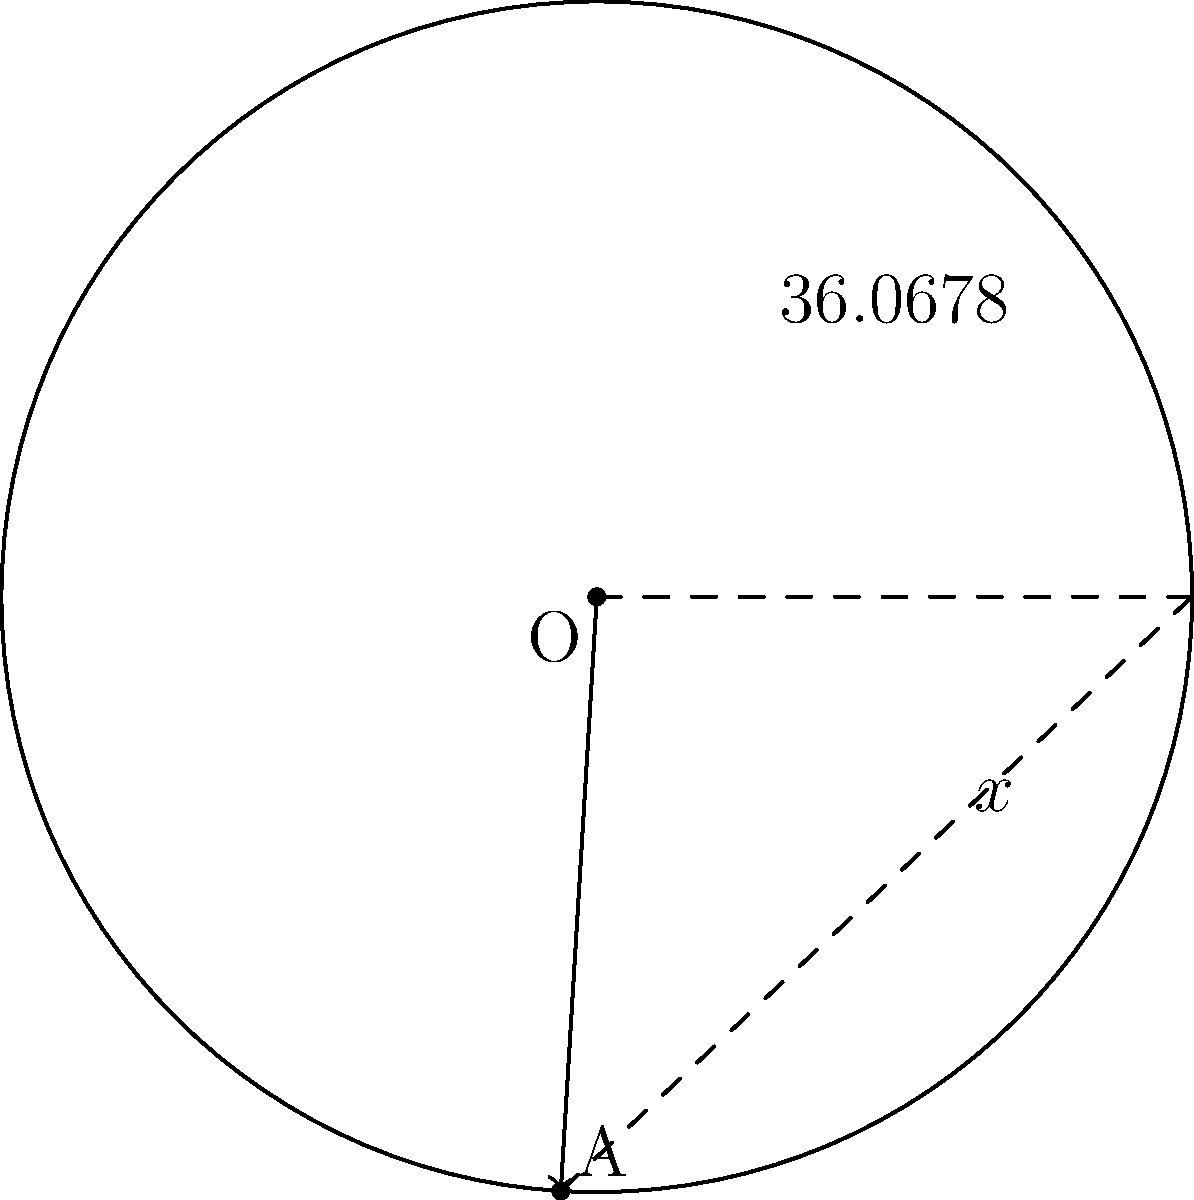Għarb's approximate latitude and longitude coordinates are 36.0678°N and 14.2008°E. If we consider the angle formed by these coordinates on a circle, what is the measure of its complementary angle $x$? To find the complementary angle, we need to follow these steps:

1) Recall that complementary angles are two angles that add up to 90°.

2) We're given the latitude of Għarb: 36.0678°N.

3) The complementary angle $x$ can be found using the equation:
   
   $x + 36.0678° = 90°$

4) Solving for $x$:
   
   $x = 90° - 36.0678°$

5) Calculate:
   
   $x = 53.9322°$

Note: We only use the latitude in this calculation because the complementary angle is based on the angle from the equator (0° latitude) to the North Pole (90° latitude).
Answer: $53.9322°$ 